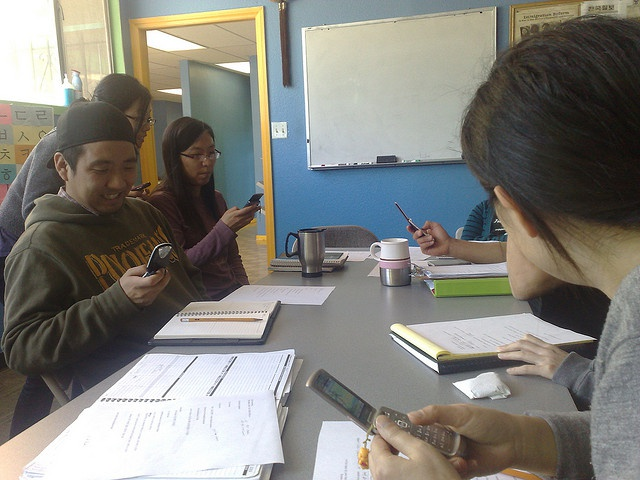Describe the objects in this image and their specific colors. I can see people in white, black, and gray tones, people in white, black, and gray tones, dining table in white, gray, and lightgray tones, book in white, darkgray, and gray tones, and people in white, black, gray, and maroon tones in this image. 